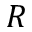Convert formula to latex. <formula><loc_0><loc_0><loc_500><loc_500>R</formula> 